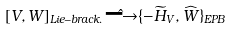Convert formula to latex. <formula><loc_0><loc_0><loc_500><loc_500>[ V , W ] _ { L i e - b r a c k . } \hat { \longrightarrow } \{ - \widetilde { H } _ { V } , \widehat { W } \} _ { E P B }</formula> 